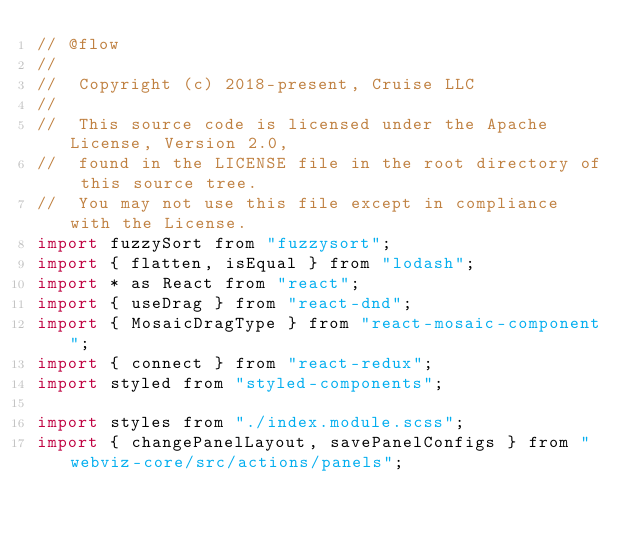<code> <loc_0><loc_0><loc_500><loc_500><_JavaScript_>// @flow
//
//  Copyright (c) 2018-present, Cruise LLC
//
//  This source code is licensed under the Apache License, Version 2.0,
//  found in the LICENSE file in the root directory of this source tree.
//  You may not use this file except in compliance with the License.
import fuzzySort from "fuzzysort";
import { flatten, isEqual } from "lodash";
import * as React from "react";
import { useDrag } from "react-dnd";
import { MosaicDragType } from "react-mosaic-component";
import { connect } from "react-redux";
import styled from "styled-components";

import styles from "./index.module.scss";
import { changePanelLayout, savePanelConfigs } from "webviz-core/src/actions/panels";</code> 